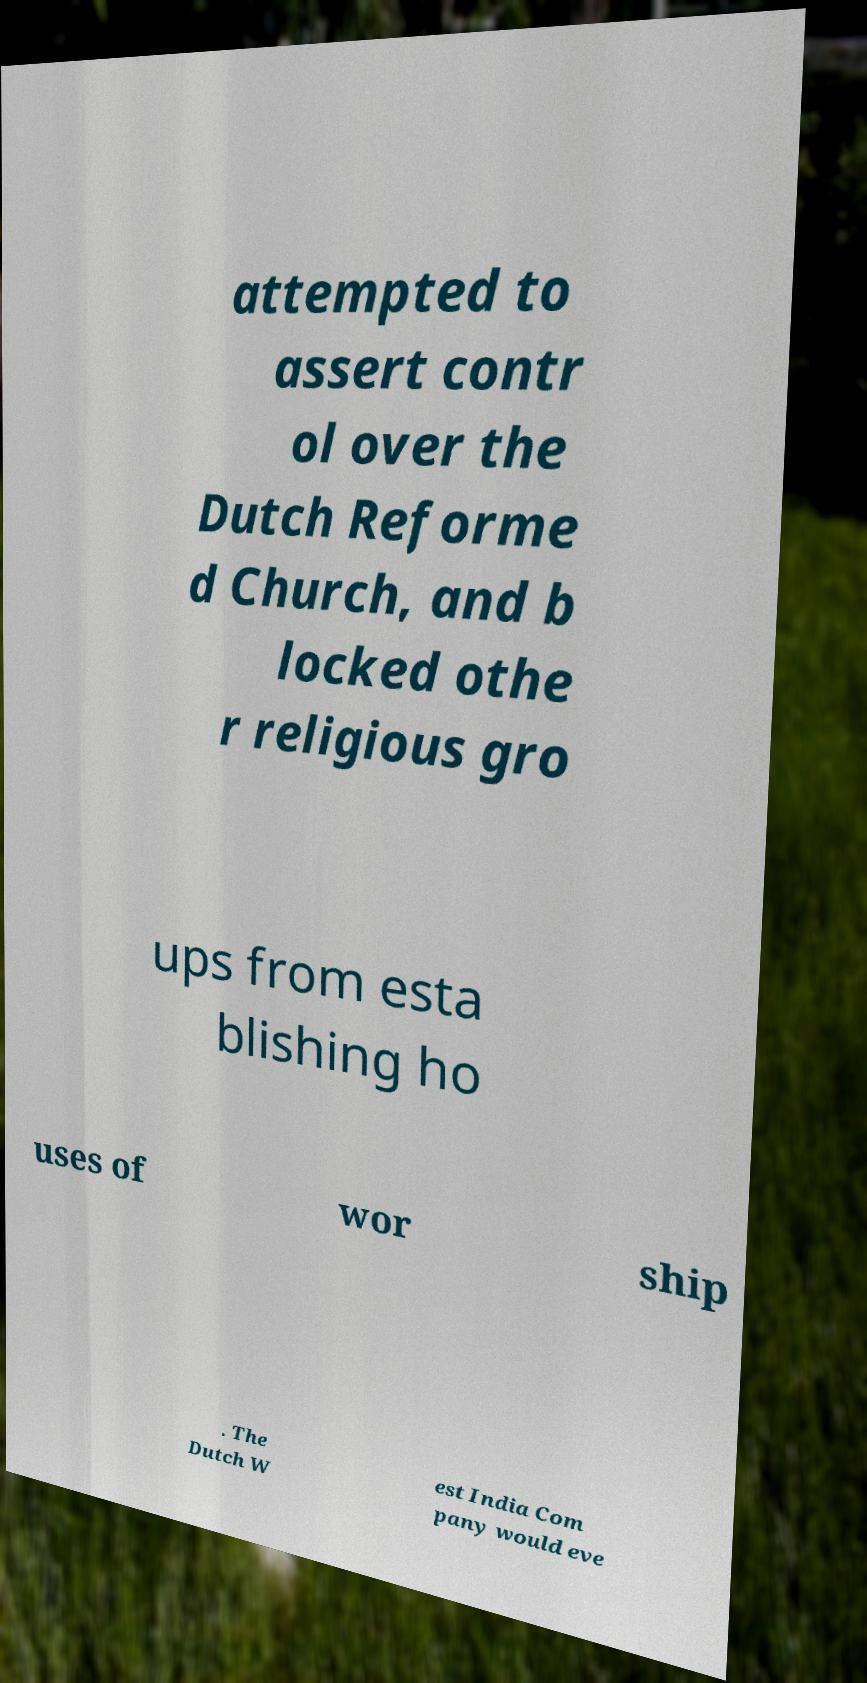For documentation purposes, I need the text within this image transcribed. Could you provide that? attempted to assert contr ol over the Dutch Reforme d Church, and b locked othe r religious gro ups from esta blishing ho uses of wor ship . The Dutch W est India Com pany would eve 